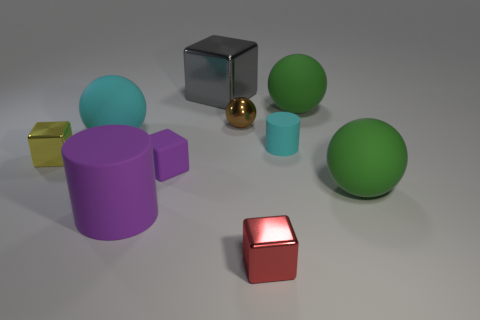Subtract all balls. How many objects are left? 6 Subtract all large green rubber objects. Subtract all small matte objects. How many objects are left? 6 Add 5 purple objects. How many purple objects are left? 7 Add 6 gray metallic objects. How many gray metallic objects exist? 7 Subtract 0 blue blocks. How many objects are left? 10 